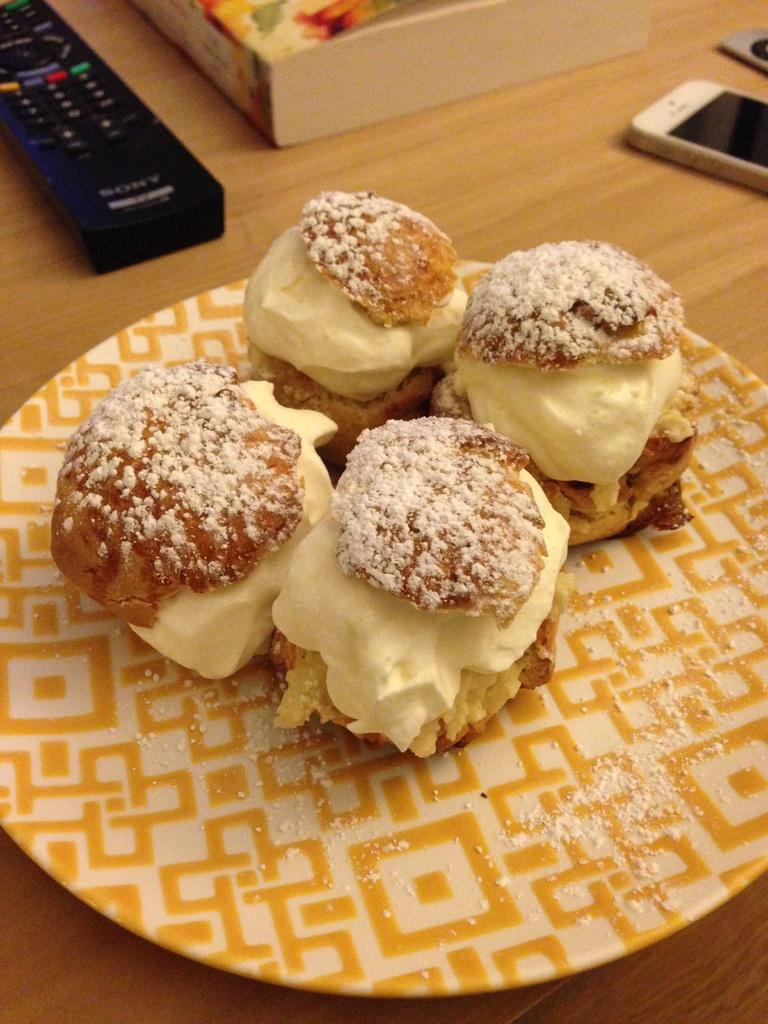How many food items are arranged on the plate in the image? There are four food items arranged on a plate in the image. Where is the plate located? The plate is on a table. What other objects can be seen on the table? There is a remote, a mobile, a box, and other unspecified objects on the table. How does the donkey contribute to the pollution in the image? There is no donkey present in the image, so it cannot contribute to any pollution. 